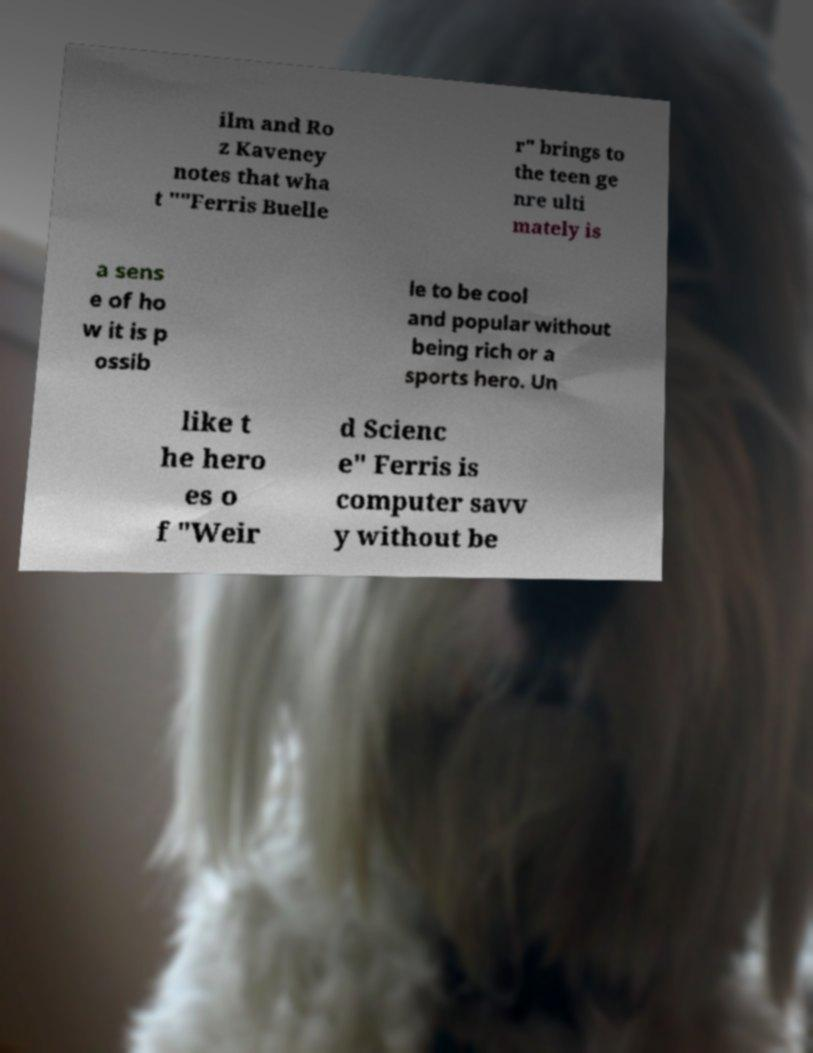Could you assist in decoding the text presented in this image and type it out clearly? ilm and Ro z Kaveney notes that wha t ""Ferris Buelle r" brings to the teen ge nre ulti mately is a sens e of ho w it is p ossib le to be cool and popular without being rich or a sports hero. Un like t he hero es o f "Weir d Scienc e" Ferris is computer savv y without be 